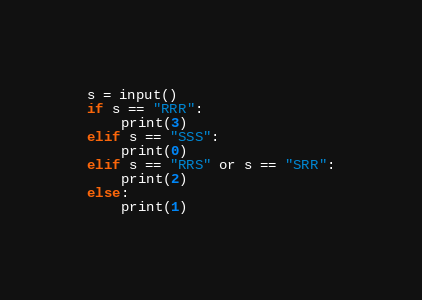<code> <loc_0><loc_0><loc_500><loc_500><_Python_>s = input()
if s == "RRR":
    print(3)
elif s == "SSS":
    print(0)
elif s == "RRS" or s == "SRR":
    print(2)
else:
    print(1)
</code> 